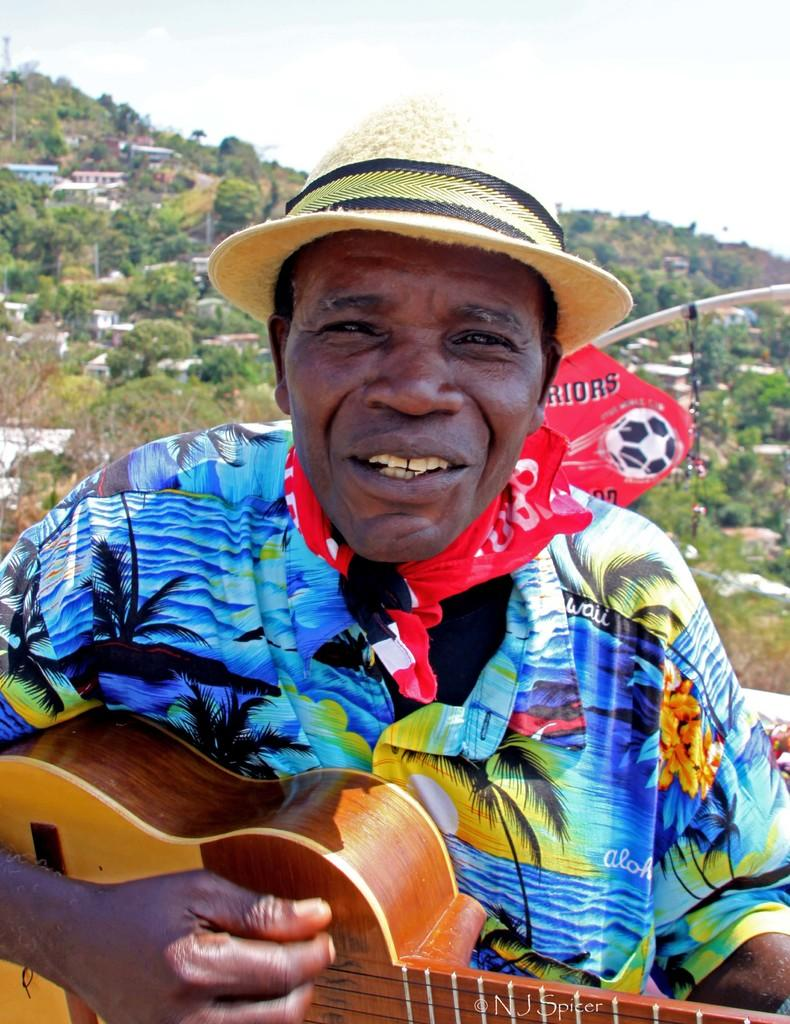Who is present in the image? There is a man in the image. What is the man wearing on his upper body? The man is wearing a colorful shirt. What accessory does the man have around his neck? The man has a red cloth around his neck. What headwear is the man wearing? The man is wearing a cap. What musical instrument is the man holding? The man is holding a guitar. What type of natural scenery can be seen in the background of the image? There are mountains, trees, and houses in the background of the image. What type of lock is the man using to secure his glove in the image? There is no lock or glove present in the image. What punishment is the man receiving for his actions in the image? There is no indication of any punishment or wrongdoing in the image. 